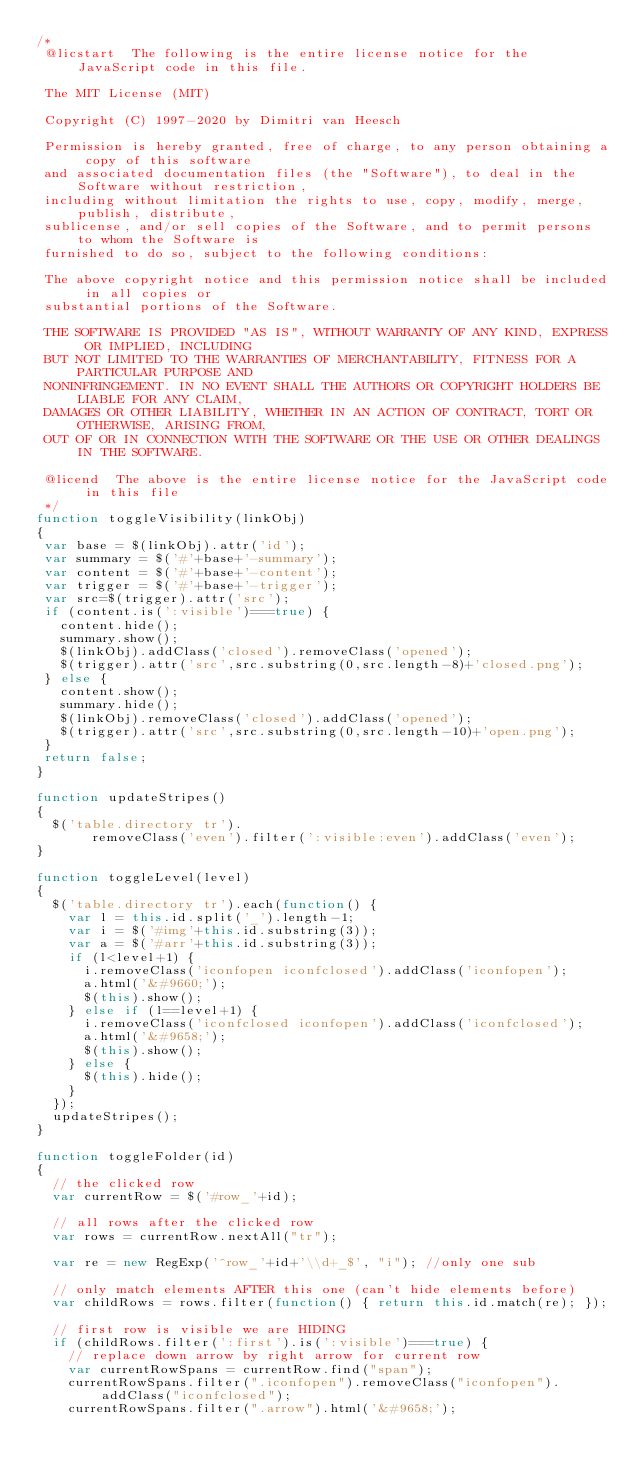<code> <loc_0><loc_0><loc_500><loc_500><_JavaScript_>/*
 @licstart  The following is the entire license notice for the JavaScript code in this file.

 The MIT License (MIT)

 Copyright (C) 1997-2020 by Dimitri van Heesch

 Permission is hereby granted, free of charge, to any person obtaining a copy of this software
 and associated documentation files (the "Software"), to deal in the Software without restriction,
 including without limitation the rights to use, copy, modify, merge, publish, distribute,
 sublicense, and/or sell copies of the Software, and to permit persons to whom the Software is
 furnished to do so, subject to the following conditions:

 The above copyright notice and this permission notice shall be included in all copies or
 substantial portions of the Software.

 THE SOFTWARE IS PROVIDED "AS IS", WITHOUT WARRANTY OF ANY KIND, EXPRESS OR IMPLIED, INCLUDING
 BUT NOT LIMITED TO THE WARRANTIES OF MERCHANTABILITY, FITNESS FOR A PARTICULAR PURPOSE AND
 NONINFRINGEMENT. IN NO EVENT SHALL THE AUTHORS OR COPYRIGHT HOLDERS BE LIABLE FOR ANY CLAIM,
 DAMAGES OR OTHER LIABILITY, WHETHER IN AN ACTION OF CONTRACT, TORT OR OTHERWISE, ARISING FROM,
 OUT OF OR IN CONNECTION WITH THE SOFTWARE OR THE USE OR OTHER DEALINGS IN THE SOFTWARE.

 @licend  The above is the entire license notice for the JavaScript code in this file
 */
function toggleVisibility(linkObj)
{
 var base = $(linkObj).attr('id');
 var summary = $('#'+base+'-summary');
 var content = $('#'+base+'-content');
 var trigger = $('#'+base+'-trigger');
 var src=$(trigger).attr('src');
 if (content.is(':visible')===true) {
   content.hide();
   summary.show();
   $(linkObj).addClass('closed').removeClass('opened');
   $(trigger).attr('src',src.substring(0,src.length-8)+'closed.png');
 } else {
   content.show();
   summary.hide();
   $(linkObj).removeClass('closed').addClass('opened');
   $(trigger).attr('src',src.substring(0,src.length-10)+'open.png');
 }
 return false;
}

function updateStripes()
{
  $('table.directory tr').
       removeClass('even').filter(':visible:even').addClass('even');
}

function toggleLevel(level)
{
  $('table.directory tr').each(function() {
    var l = this.id.split('_').length-1;
    var i = $('#img'+this.id.substring(3));
    var a = $('#arr'+this.id.substring(3));
    if (l<level+1) {
      i.removeClass('iconfopen iconfclosed').addClass('iconfopen');
      a.html('&#9660;');
      $(this).show();
    } else if (l==level+1) {
      i.removeClass('iconfclosed iconfopen').addClass('iconfclosed');
      a.html('&#9658;');
      $(this).show();
    } else {
      $(this).hide();
    }
  });
  updateStripes();
}

function toggleFolder(id)
{
  // the clicked row
  var currentRow = $('#row_'+id);

  // all rows after the clicked row
  var rows = currentRow.nextAll("tr");

  var re = new RegExp('^row_'+id+'\\d+_$', "i"); //only one sub

  // only match elements AFTER this one (can't hide elements before)
  var childRows = rows.filter(function() { return this.id.match(re); });

  // first row is visible we are HIDING
  if (childRows.filter(':first').is(':visible')===true) {
    // replace down arrow by right arrow for current row
    var currentRowSpans = currentRow.find("span");
    currentRowSpans.filter(".iconfopen").removeClass("iconfopen").addClass("iconfclosed");
    currentRowSpans.filter(".arrow").html('&#9658;');</code> 